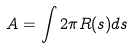Convert formula to latex. <formula><loc_0><loc_0><loc_500><loc_500>A = \int 2 \pi R ( s ) d s</formula> 